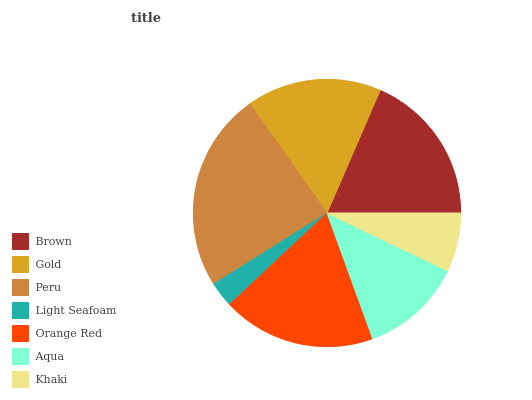Is Light Seafoam the minimum?
Answer yes or no. Yes. Is Peru the maximum?
Answer yes or no. Yes. Is Gold the minimum?
Answer yes or no. No. Is Gold the maximum?
Answer yes or no. No. Is Brown greater than Gold?
Answer yes or no. Yes. Is Gold less than Brown?
Answer yes or no. Yes. Is Gold greater than Brown?
Answer yes or no. No. Is Brown less than Gold?
Answer yes or no. No. Is Gold the high median?
Answer yes or no. Yes. Is Gold the low median?
Answer yes or no. Yes. Is Brown the high median?
Answer yes or no. No. Is Orange Red the low median?
Answer yes or no. No. 